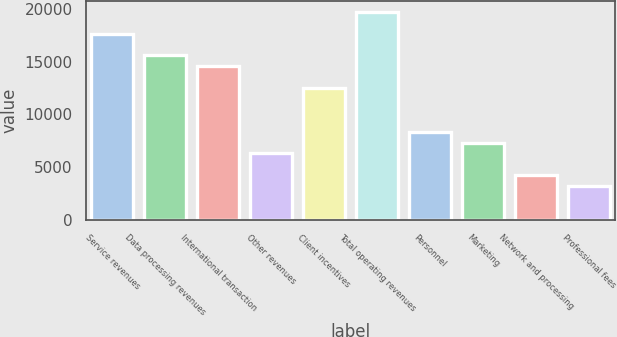Convert chart to OTSL. <chart><loc_0><loc_0><loc_500><loc_500><bar_chart><fcel>Service revenues<fcel>Data processing revenues<fcel>International transaction<fcel>Other revenues<fcel>Client incentives<fcel>Total operating revenues<fcel>Personnel<fcel>Marketing<fcel>Network and processing<fcel>Professional fees<nl><fcel>17670.2<fcel>15599<fcel>14563.4<fcel>6278.6<fcel>12492.2<fcel>19741.4<fcel>8349.8<fcel>7314.2<fcel>4207.4<fcel>3171.8<nl></chart> 